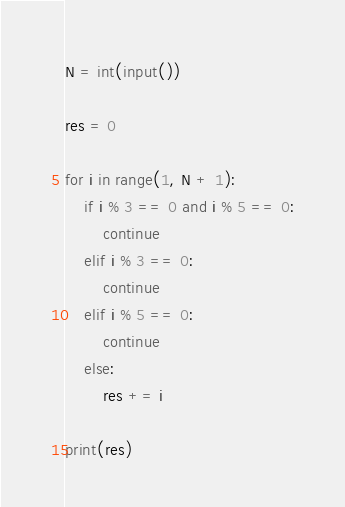Convert code to text. <code><loc_0><loc_0><loc_500><loc_500><_Python_>N = int(input())

res = 0

for i in range(1, N + 1):
    if i % 3 == 0 and i % 5 == 0:
        continue
    elif i % 3 == 0:
        continue
    elif i % 5 == 0:
        continue
    else:
        res += i

print(res)</code> 